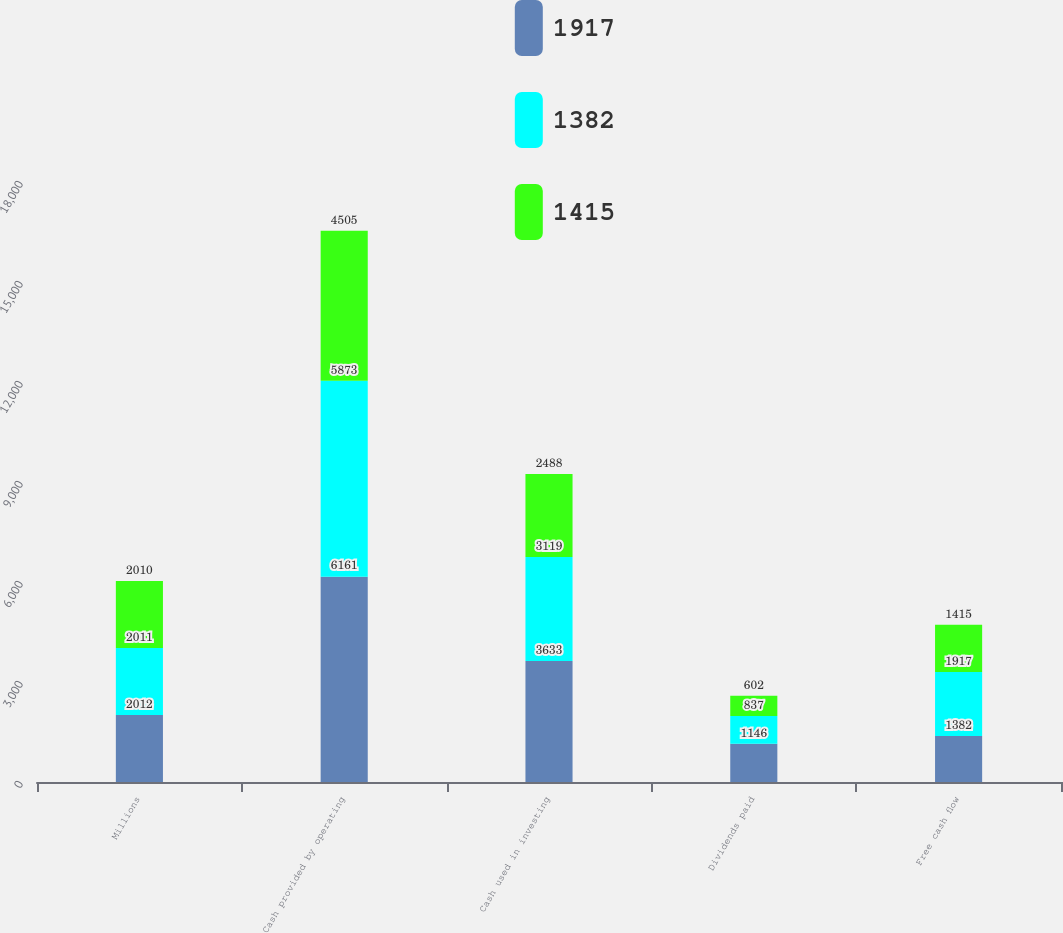Convert chart. <chart><loc_0><loc_0><loc_500><loc_500><stacked_bar_chart><ecel><fcel>Millions<fcel>Cash provided by operating<fcel>Cash used in investing<fcel>Dividends paid<fcel>Free cash flow<nl><fcel>1917<fcel>2012<fcel>6161<fcel>3633<fcel>1146<fcel>1382<nl><fcel>1382<fcel>2011<fcel>5873<fcel>3119<fcel>837<fcel>1917<nl><fcel>1415<fcel>2010<fcel>4505<fcel>2488<fcel>602<fcel>1415<nl></chart> 